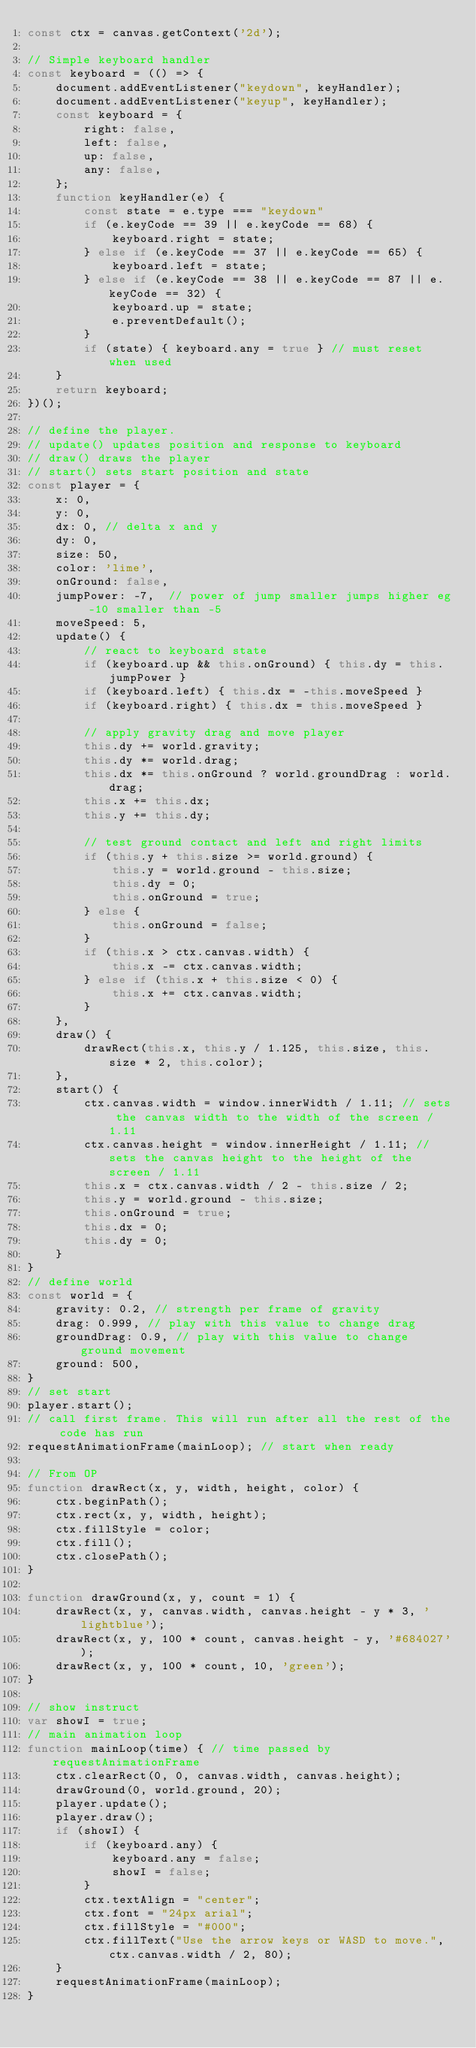<code> <loc_0><loc_0><loc_500><loc_500><_JavaScript_>const ctx = canvas.getContext('2d');

// Simple keyboard handler
const keyboard = (() => {
    document.addEventListener("keydown", keyHandler);
    document.addEventListener("keyup", keyHandler);
    const keyboard = {
        right: false,
        left: false,
        up: false,
        any: false,
    };
    function keyHandler(e) {
        const state = e.type === "keydown"
        if (e.keyCode == 39 || e.keyCode == 68) {
            keyboard.right = state;
        } else if (e.keyCode == 37 || e.keyCode == 65) {
            keyboard.left = state;
        } else if (e.keyCode == 38 || e.keyCode == 87 || e.keyCode == 32) {
            keyboard.up = state;
            e.preventDefault();
        }
        if (state) { keyboard.any = true } // must reset when used
    }
    return keyboard;
})();

// define the player.
// update() updates position and response to keyboard
// draw() draws the player
// start() sets start position and state
const player = {
    x: 0,
    y: 0,
    dx: 0, // delta x and y
    dy: 0,
    size: 50,
    color: 'lime',
    onGround: false,
    jumpPower: -7,  // power of jump smaller jumps higher eg -10 smaller than -5
    moveSpeed: 5,
    update() {
        // react to keyboard state
        if (keyboard.up && this.onGround) { this.dy = this.jumpPower }
        if (keyboard.left) { this.dx = -this.moveSpeed }
        if (keyboard.right) { this.dx = this.moveSpeed }

        // apply gravity drag and move player
        this.dy += world.gravity;
        this.dy *= world.drag;
        this.dx *= this.onGround ? world.groundDrag : world.drag;
        this.x += this.dx;
        this.y += this.dy;

        // test ground contact and left and right limits
        if (this.y + this.size >= world.ground) {
            this.y = world.ground - this.size;
            this.dy = 0;
            this.onGround = true;
        } else {
            this.onGround = false;
        }
        if (this.x > ctx.canvas.width) {
            this.x -= ctx.canvas.width;
        } else if (this.x + this.size < 0) {
            this.x += ctx.canvas.width;
        }
    },
    draw() {
        drawRect(this.x, this.y / 1.125, this.size, this.size * 2, this.color);
    },
    start() {
        ctx.canvas.width = window.innerWidth / 1.11; // sets the canvas width to the width of the screen / 1.11
        ctx.canvas.height = window.innerHeight / 1.11; // sets the canvas height to the height of the screen / 1.11
        this.x = ctx.canvas.width / 2 - this.size / 2;
        this.y = world.ground - this.size;
        this.onGround = true;
        this.dx = 0;
        this.dy = 0;
    }
}
// define world
const world = {
    gravity: 0.2, // strength per frame of gravity
    drag: 0.999, // play with this value to change drag
    groundDrag: 0.9, // play with this value to change ground movement
    ground: 500,
}
// set start
player.start();
// call first frame. This will run after all the rest of the code has run
requestAnimationFrame(mainLoop); // start when ready

// From OP
function drawRect(x, y, width, height, color) {
    ctx.beginPath();
    ctx.rect(x, y, width, height);
    ctx.fillStyle = color;
    ctx.fill();
    ctx.closePath();
}

function drawGround(x, y, count = 1) {
    drawRect(x, y, canvas.width, canvas.height - y * 3, 'lightblue');
    drawRect(x, y, 100 * count, canvas.height - y, '#684027');
    drawRect(x, y, 100 * count, 10, 'green');
}

// show instruct
var showI = true;
// main animation loop
function mainLoop(time) { // time passed by requestAnimationFrame        
    ctx.clearRect(0, 0, canvas.width, canvas.height);
    drawGround(0, world.ground, 20);
    player.update();
    player.draw();
    if (showI) {
        if (keyboard.any) {
            keyboard.any = false;
            showI = false;
        }
        ctx.textAlign = "center";
        ctx.font = "24px arial";
        ctx.fillStyle = "#000";
        ctx.fillText("Use the arrow keys or WASD to move.", ctx.canvas.width / 2, 80);
    }
    requestAnimationFrame(mainLoop);
}</code> 